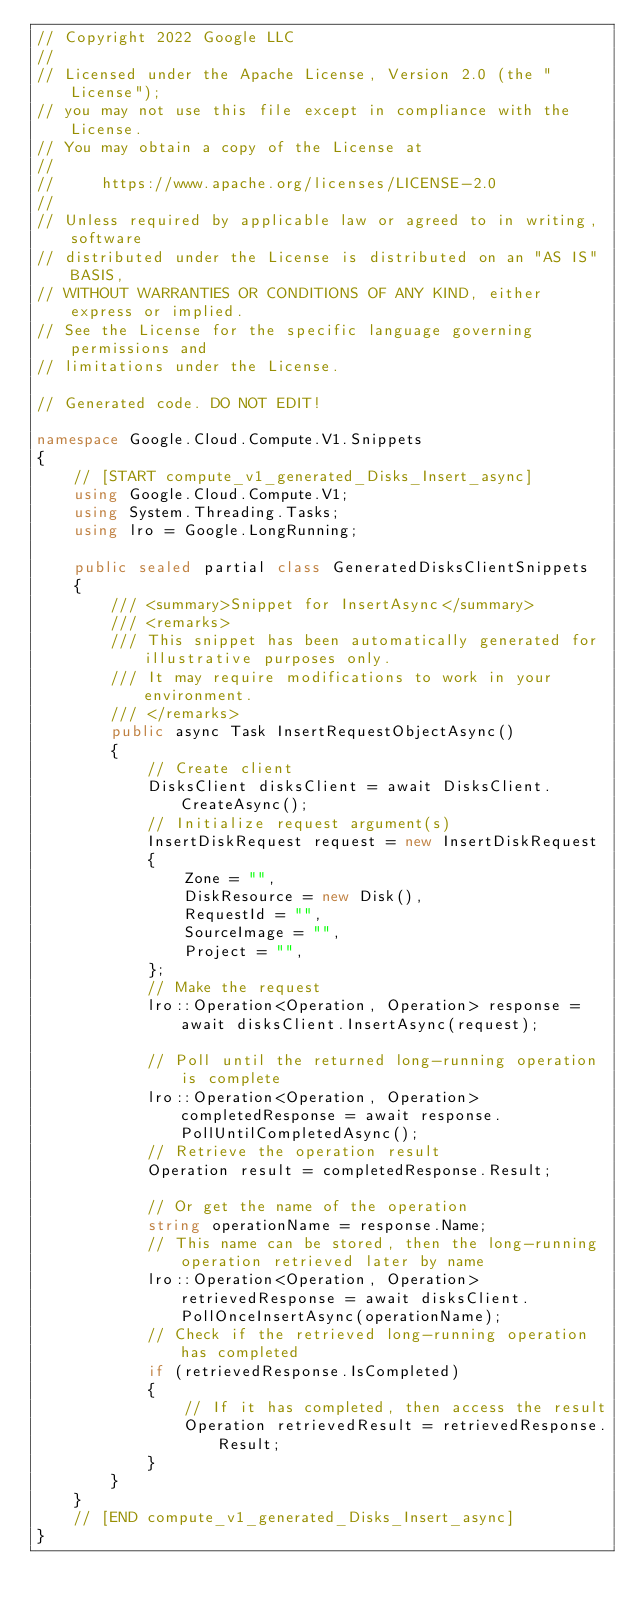Convert code to text. <code><loc_0><loc_0><loc_500><loc_500><_C#_>// Copyright 2022 Google LLC
//
// Licensed under the Apache License, Version 2.0 (the "License");
// you may not use this file except in compliance with the License.
// You may obtain a copy of the License at
//
//     https://www.apache.org/licenses/LICENSE-2.0
//
// Unless required by applicable law or agreed to in writing, software
// distributed under the License is distributed on an "AS IS" BASIS,
// WITHOUT WARRANTIES OR CONDITIONS OF ANY KIND, either express or implied.
// See the License for the specific language governing permissions and
// limitations under the License.

// Generated code. DO NOT EDIT!

namespace Google.Cloud.Compute.V1.Snippets
{
    // [START compute_v1_generated_Disks_Insert_async]
    using Google.Cloud.Compute.V1;
    using System.Threading.Tasks;
    using lro = Google.LongRunning;

    public sealed partial class GeneratedDisksClientSnippets
    {
        /// <summary>Snippet for InsertAsync</summary>
        /// <remarks>
        /// This snippet has been automatically generated for illustrative purposes only.
        /// It may require modifications to work in your environment.
        /// </remarks>
        public async Task InsertRequestObjectAsync()
        {
            // Create client
            DisksClient disksClient = await DisksClient.CreateAsync();
            // Initialize request argument(s)
            InsertDiskRequest request = new InsertDiskRequest
            {
                Zone = "",
                DiskResource = new Disk(),
                RequestId = "",
                SourceImage = "",
                Project = "",
            };
            // Make the request
            lro::Operation<Operation, Operation> response = await disksClient.InsertAsync(request);

            // Poll until the returned long-running operation is complete
            lro::Operation<Operation, Operation> completedResponse = await response.PollUntilCompletedAsync();
            // Retrieve the operation result
            Operation result = completedResponse.Result;

            // Or get the name of the operation
            string operationName = response.Name;
            // This name can be stored, then the long-running operation retrieved later by name
            lro::Operation<Operation, Operation> retrievedResponse = await disksClient.PollOnceInsertAsync(operationName);
            // Check if the retrieved long-running operation has completed
            if (retrievedResponse.IsCompleted)
            {
                // If it has completed, then access the result
                Operation retrievedResult = retrievedResponse.Result;
            }
        }
    }
    // [END compute_v1_generated_Disks_Insert_async]
}
</code> 